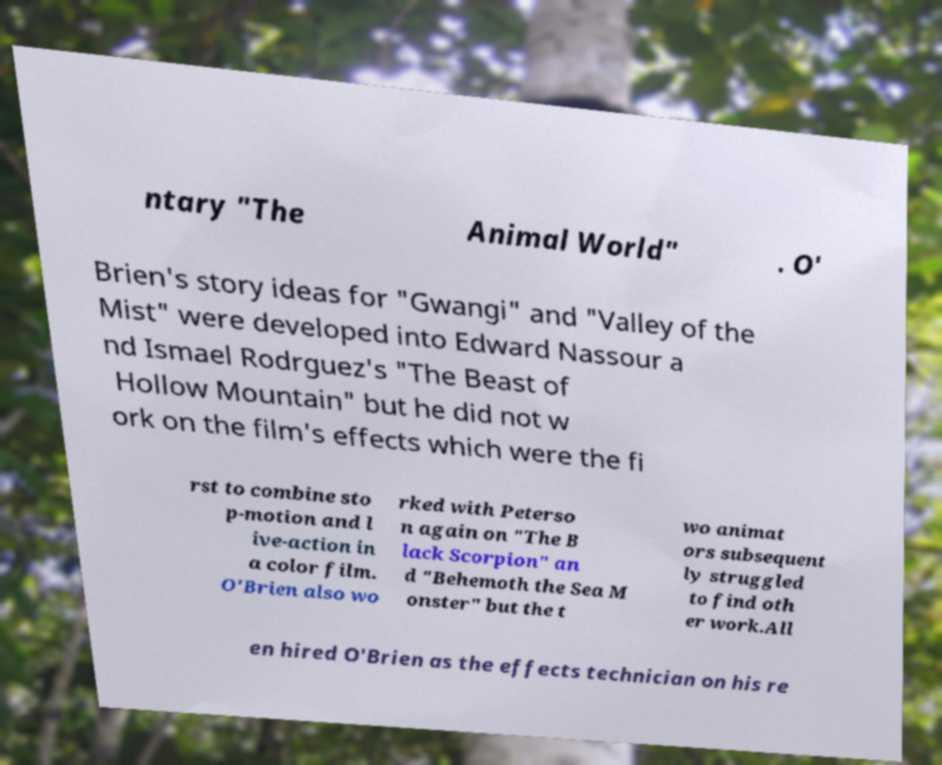Could you assist in decoding the text presented in this image and type it out clearly? ntary "The Animal World" . O' Brien's story ideas for "Gwangi" and "Valley of the Mist" were developed into Edward Nassour a nd Ismael Rodrguez's "The Beast of Hollow Mountain" but he did not w ork on the film's effects which were the fi rst to combine sto p-motion and l ive-action in a color film. O'Brien also wo rked with Peterso n again on "The B lack Scorpion" an d "Behemoth the Sea M onster" but the t wo animat ors subsequent ly struggled to find oth er work.All en hired O'Brien as the effects technician on his re 